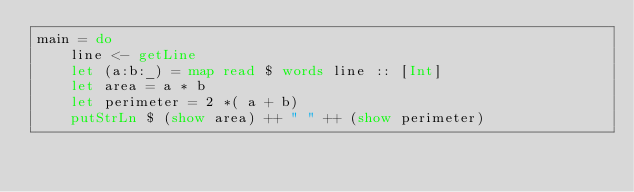Convert code to text. <code><loc_0><loc_0><loc_500><loc_500><_Haskell_>main = do
    line <- getLine
    let (a:b:_) = map read $ words line :: [Int]
    let area = a * b
    let perimeter = 2 *( a + b)
    putStrLn $ (show area) ++ " " ++ (show perimeter)
</code> 